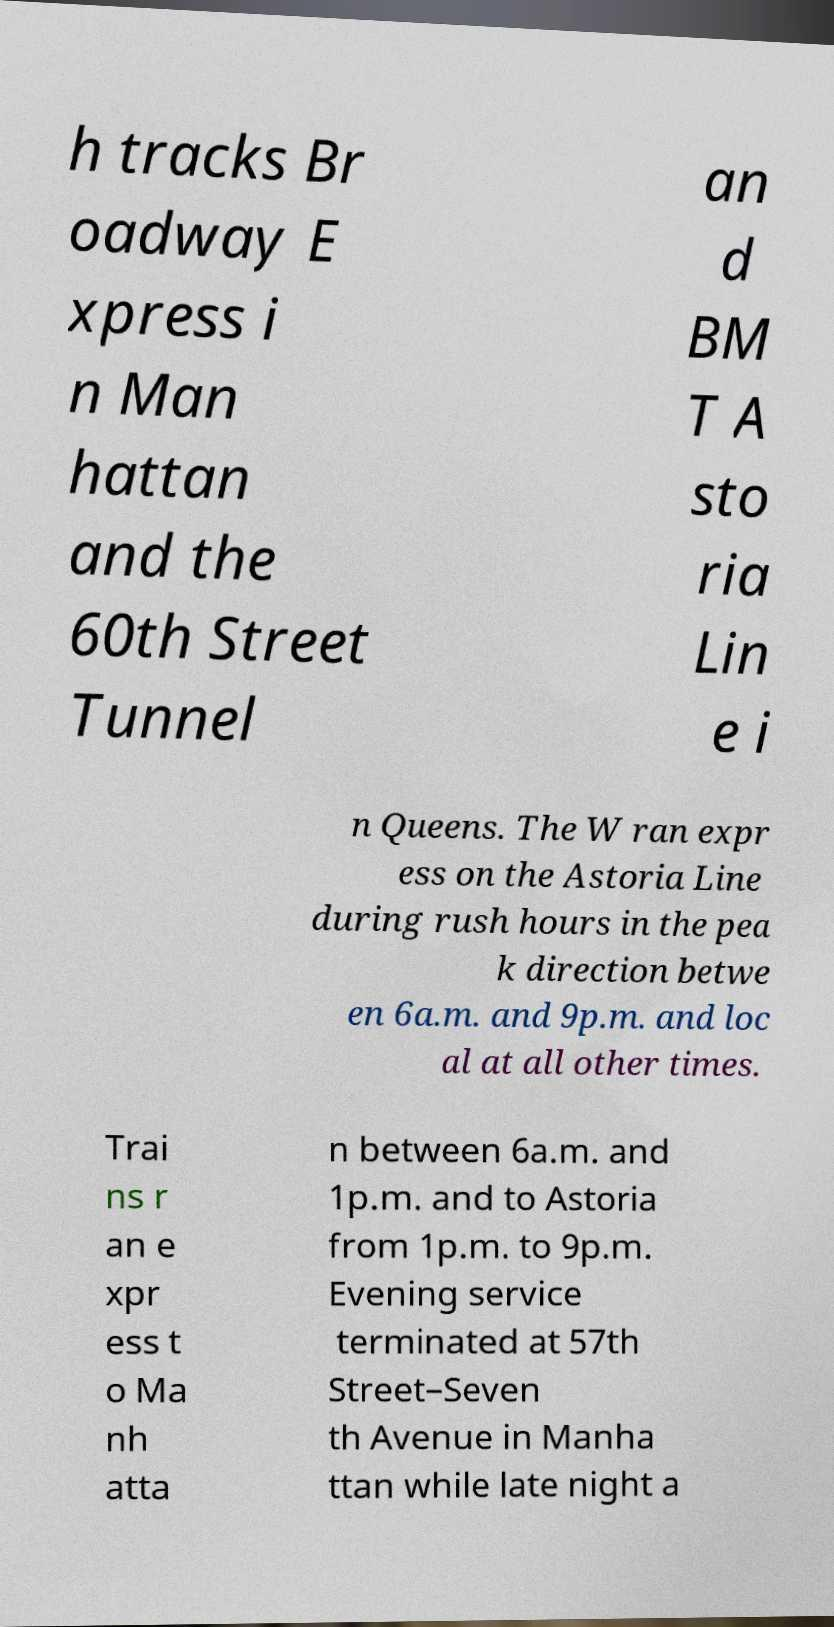Please read and relay the text visible in this image. What does it say? h tracks Br oadway E xpress i n Man hattan and the 60th Street Tunnel an d BM T A sto ria Lin e i n Queens. The W ran expr ess on the Astoria Line during rush hours in the pea k direction betwe en 6a.m. and 9p.m. and loc al at all other times. Trai ns r an e xpr ess t o Ma nh atta n between 6a.m. and 1p.m. and to Astoria from 1p.m. to 9p.m. Evening service terminated at 57th Street–Seven th Avenue in Manha ttan while late night a 